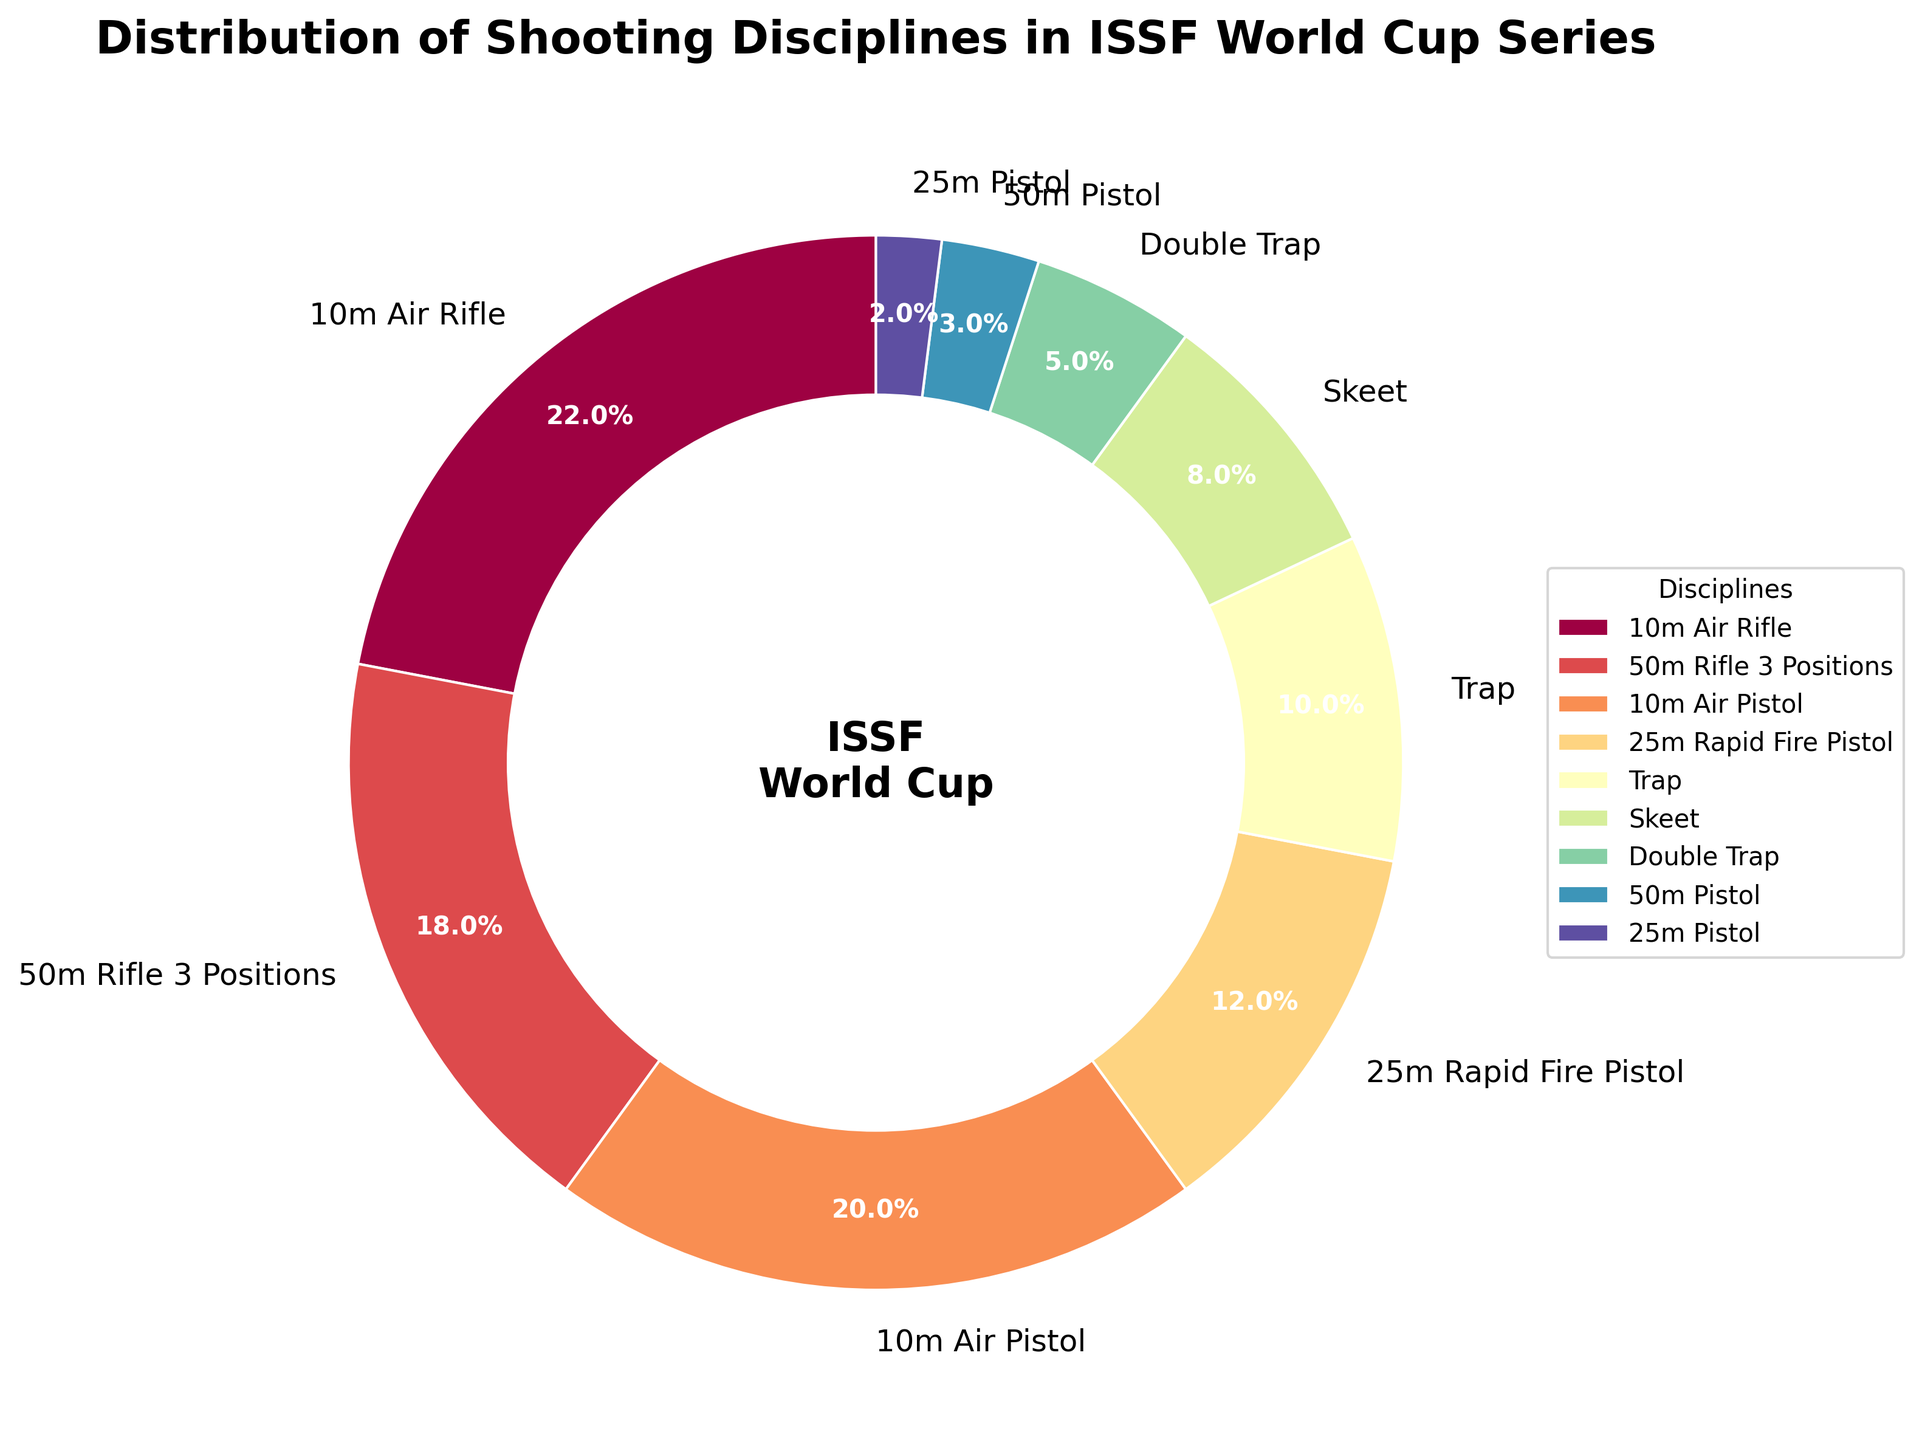What percentage of the ISSF World Cup series does the 10m Air Rifle discipline represent? By looking at the figure, the 10m Air Rifle discipline has a labeled percentage value associated with it. Just directly refer to the figure for this value.
Answer: 22% Which discipline accounts for a larger portion: Trap or Skeet? Compare the labeled percentages of Trap and Skeet. Trap is 10% and Skeet is 8%.
Answer: Trap How much more popular is 10m Air Rifle compared to 25m Rapid Fire Pistol? Subtract the percentage of 25m Rapid Fire Pistol from the percentage of 10m Air Rifle (22% - 12%).
Answer: 10% What is the combined percentage of the disciplines categorized under Pistol shooting (10m Air Pistol, 25m Rapid Fire Pistol, 50m Pistol, 25m Pistol)? Add the percentages of 10m Air Pistol (20%), 25m Rapid Fire Pistol (12%), 50m Pistol (3%), and 25m Pistol (2%). (20% + 12% + 3% + 2%)
Answer: 37% Which discipline has the smallest representation? Identify the discipline with the smallest labeled percentage. The 25m Pistol has 2%, the smallest in the series.
Answer: 25m Pistol What are the two largest disciplines in the ISSF World Cup series? Look for the two largest wedges in the pie chart, which are 10m Air Rifle (22%) and 10m Air Pistol (20%).
Answer: 10m Air Rifle and 10m Air Pistol What's the difference in percentage representation between Double Trap and Skeet? Subtract the percentage of Double Trap (5%) from Skeet (8%).
Answer: 3% What proportion of the ISSF World Cup series is made up by Rifle disciplines (10m Air Rifle, 50m Rifle 3 Positions)? Add the percentages of 10m Air Rifle (22%) and 50m Rifle 3 Positions (18%). (22% + 18%)
Answer: 40% If you group Rifle and Pistol disciplines together, what overall percentage do they represent? Sum the percentages of all Rifle (22% + 18%) and Pistol (20% + 12% + 3% + 2%) disciplines. (22% + 18% + 20% + 12% + 3% + 2%)
Answer: 77% Which disciplines combined account for half of the total distribution? Check which combination of disciplines adds up to around 50%. The 10m Air Rifle (22%), 10m Air Pistol (20%), and 50m Rifle 3 Positions (18%) together total 60%, while other combinations will either lie below or above 50%.
Answer: 10m Air Rifle and 10m Air Pistol 